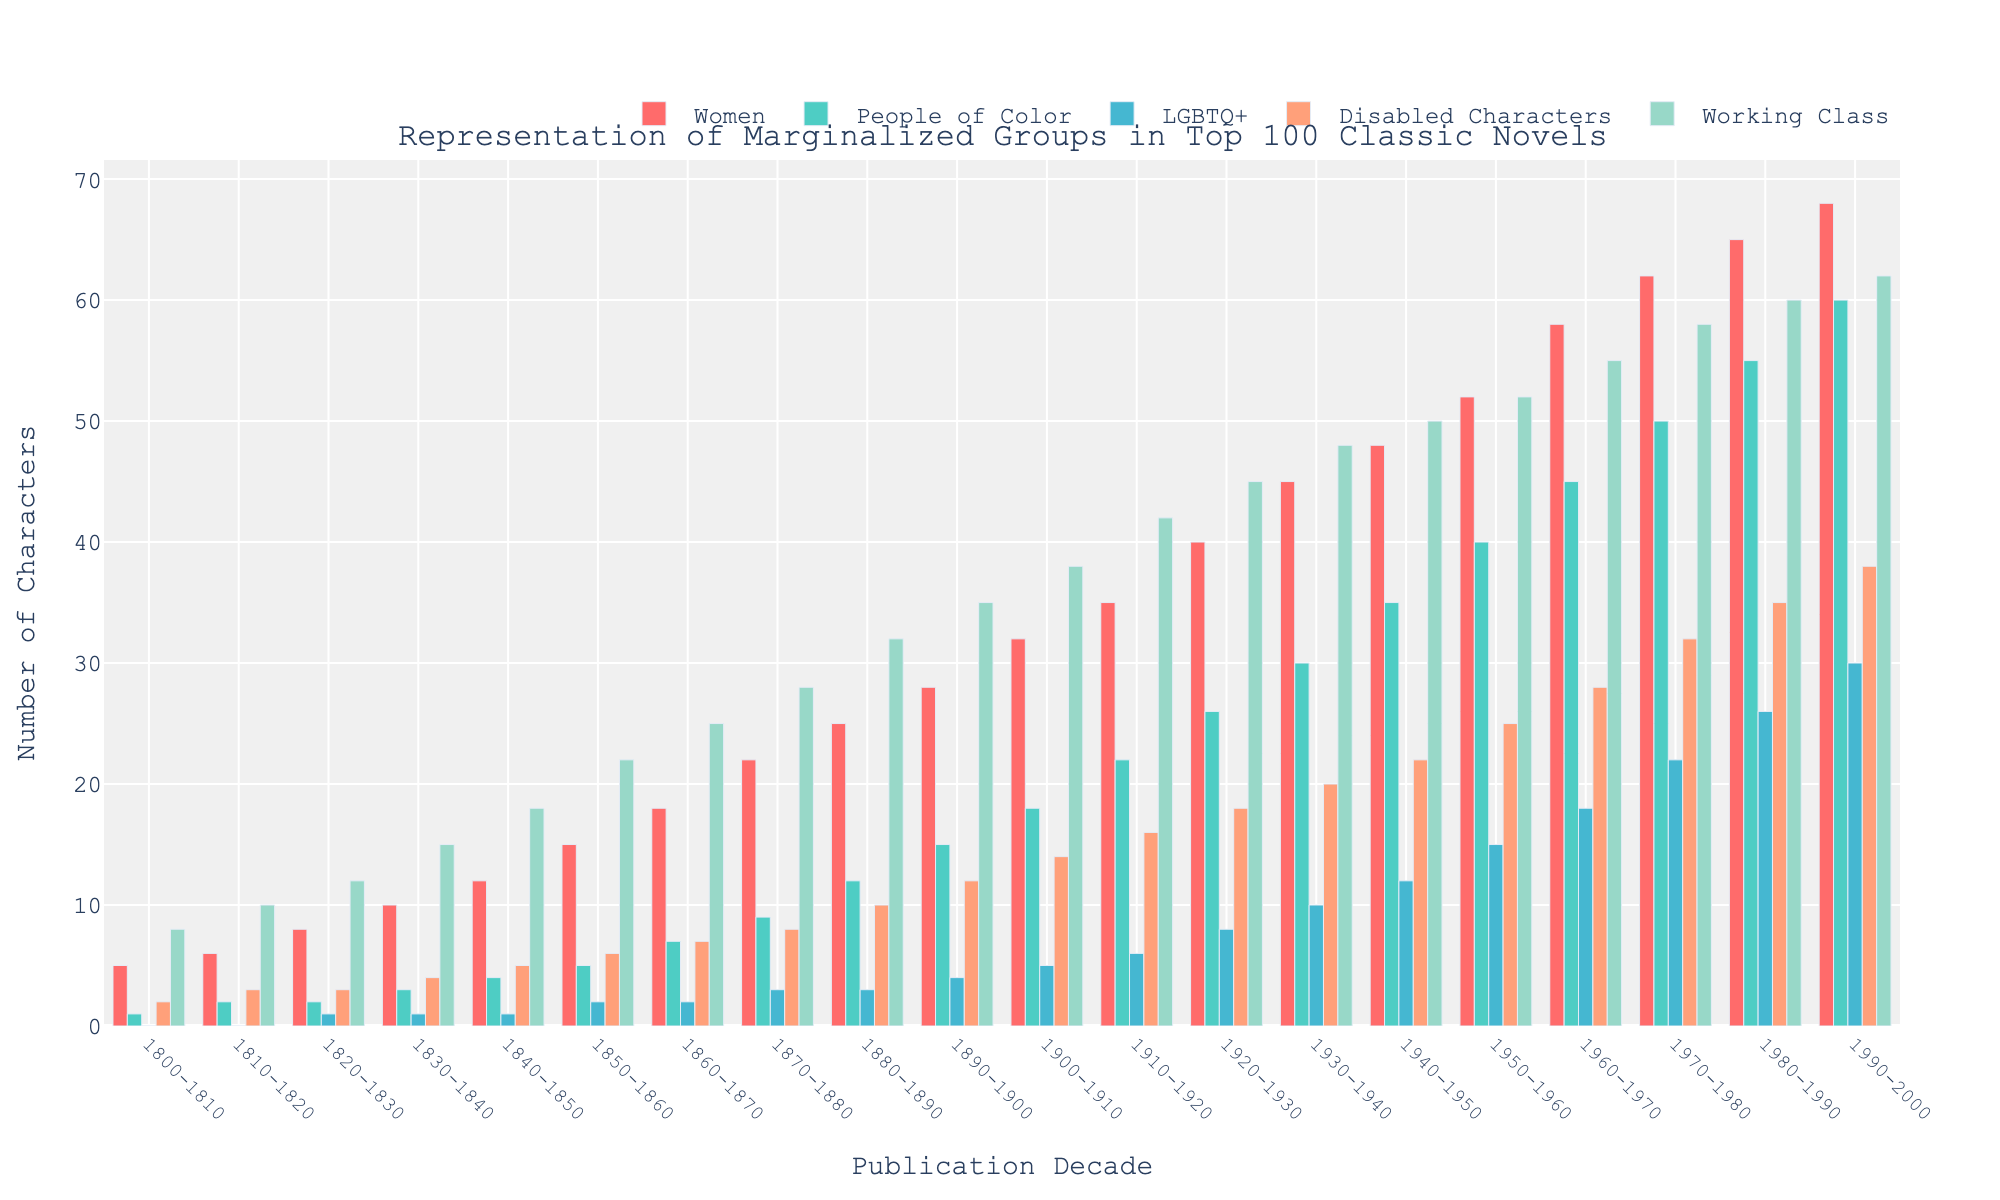Which group has the highest representation in the 1900-1910 decade? To find the highest representation in the 1900-1910 decade, check the bar heights for each group in that decade. The group with the tallest bar is the "Women" group.
Answer: Women Between 1800-1810 and 1990-2000, which decade shows the most significant increase in the representation of People of Color? Calculate the difference in the number of People of Color characters between consecutive decades and identify the maximum increase. The decade with the most considerable increase is 1930-1940, with an increase of 5 characters (from 30 to 35).
Answer: 1930-1940 What is the total number of characters represented from the Working Class group across all decades? Sum the values of the Working Class group from all decades: 8+10+12+15+18+22+25+28+32+35+38+42+45+48+50+52+55+58+60+62 = 625 characters.
Answer: 625 How does the representation of LGBTQ+ characters change from the 1850-1860 decade to the 1950-1960 decade? Subtract the number of LGBTQ+ characters in 1850-1860 from the 1950-1960 count: 15 - 2 = 13. Thus, the representation increased by 13 characters.
Answer: Increased by 13 Which group shows the least consistent representation across decades and how can it be identified visually? To identify the least consistent group, look for the group with the most variable bar heights across all decades. "LGBTQ+" characters have the least consistency, as their bar heights show the most fluctuations.
Answer: LGBTQ+ What is the average representation of Disabled Characters in the first half of the 20th century (1900-1950)? Calculate the sum of Disabled Characters from 1900 to 1950 and divide it by the number of decades: (14+16+18+20+22)/5 = 18.
Answer: 18 Between the 1800-1810 and 1990-2000 decades, which group had the least cumulative increase in representation? Calculate the difference in the number of characters between 1800-1810 and 1990-2000 for each group, and identify the smallest increase:
- Women: 68-5 = 63
- People of Color: 60-1 = 59
- LGBTQ+: 30-0 = 30
- Disabled Characters: 38-2 = 36
- Working Class: 62-8 = 54
The smallest increase is for Disabled Characters.
Answer: Disabled Characters Which decade first shows a representation of LGBTQ+ characters? Identify the first decade where the LGBTQ+ group has a non-zero value. The first decade is 1820-1830, with 1 LGBTQ+ character.
Answer: 1820-1830 What is the combined representation of Women and Working Class characters in the decade 1920-1930? Sum the values of Women and Working Class characters in 1920-1930: 40 + 45 = 85 characters.
Answer: 85 